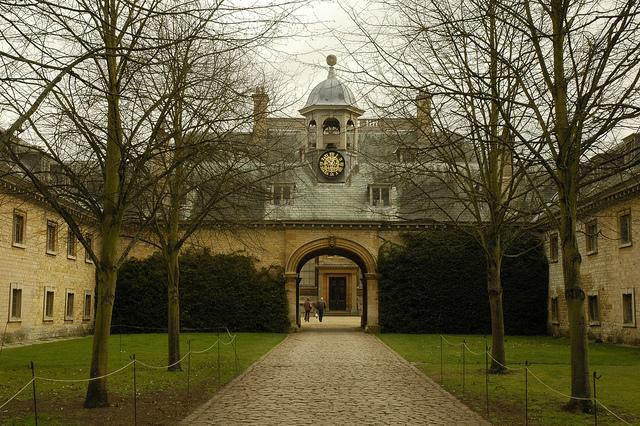What does this setting most resemble? Please explain your reasoning. college campus. The setting is a college campus. 